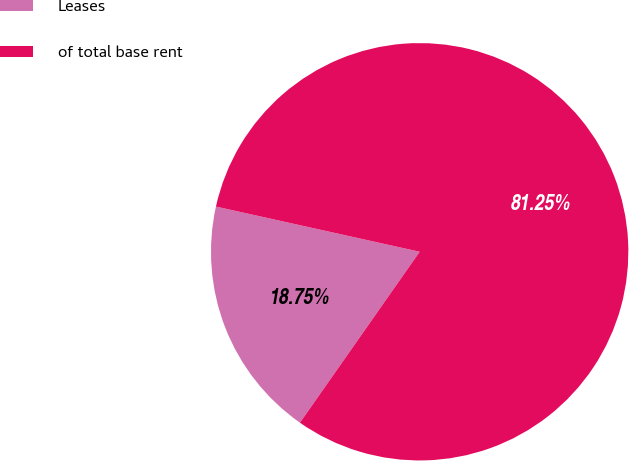Convert chart. <chart><loc_0><loc_0><loc_500><loc_500><pie_chart><fcel>Leases<fcel>of total base rent<nl><fcel>18.75%<fcel>81.25%<nl></chart> 